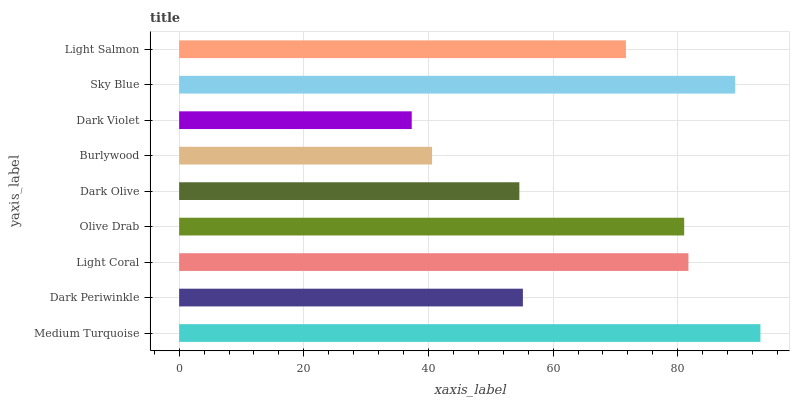Is Dark Violet the minimum?
Answer yes or no. Yes. Is Medium Turquoise the maximum?
Answer yes or no. Yes. Is Dark Periwinkle the minimum?
Answer yes or no. No. Is Dark Periwinkle the maximum?
Answer yes or no. No. Is Medium Turquoise greater than Dark Periwinkle?
Answer yes or no. Yes. Is Dark Periwinkle less than Medium Turquoise?
Answer yes or no. Yes. Is Dark Periwinkle greater than Medium Turquoise?
Answer yes or no. No. Is Medium Turquoise less than Dark Periwinkle?
Answer yes or no. No. Is Light Salmon the high median?
Answer yes or no. Yes. Is Light Salmon the low median?
Answer yes or no. Yes. Is Burlywood the high median?
Answer yes or no. No. Is Dark Olive the low median?
Answer yes or no. No. 